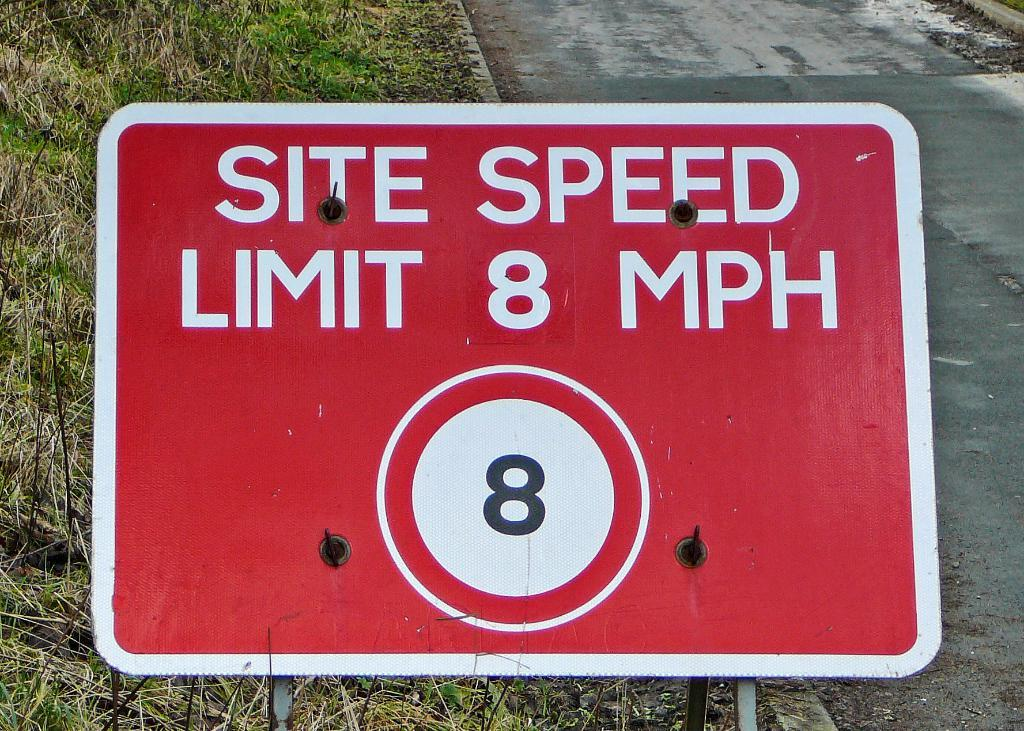<image>
Present a compact description of the photo's key features. A red sign states the speed limit is 8 miles per hour. 